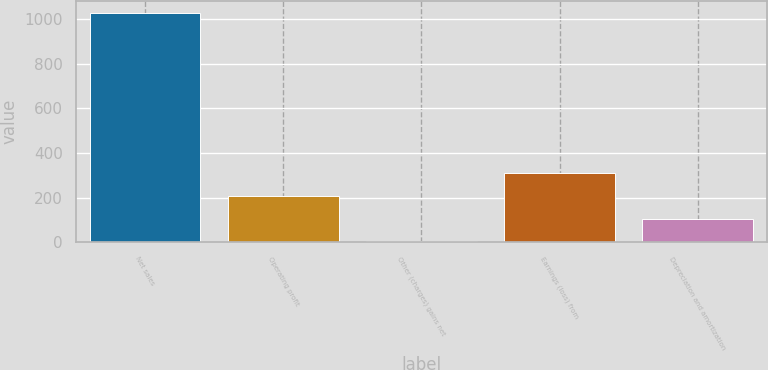<chart> <loc_0><loc_0><loc_500><loc_500><bar_chart><fcel>Net sales<fcel>Operating profit<fcel>Other (charges) gains net<fcel>Earnings (loss) from<fcel>Depreciation and amortization<nl><fcel>1030<fcel>209.2<fcel>4<fcel>311.8<fcel>106.6<nl></chart> 